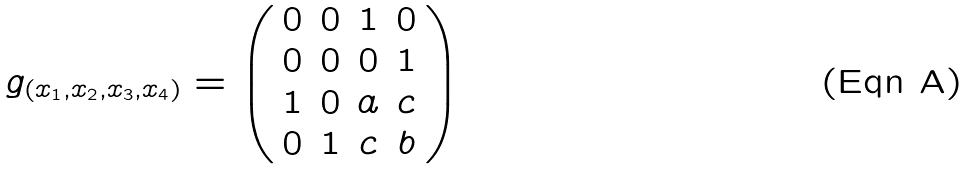<formula> <loc_0><loc_0><loc_500><loc_500>g _ { ( x _ { 1 } , x _ { 2 } , x _ { 3 } , x _ { 4 } ) } = \left ( \begin{array} { c c c c } 0 & 0 & 1 & 0 \\ 0 & 0 & 0 & 1 \\ 1 & 0 & a & c \\ 0 & 1 & c & b \\ \end{array} \right )</formula> 